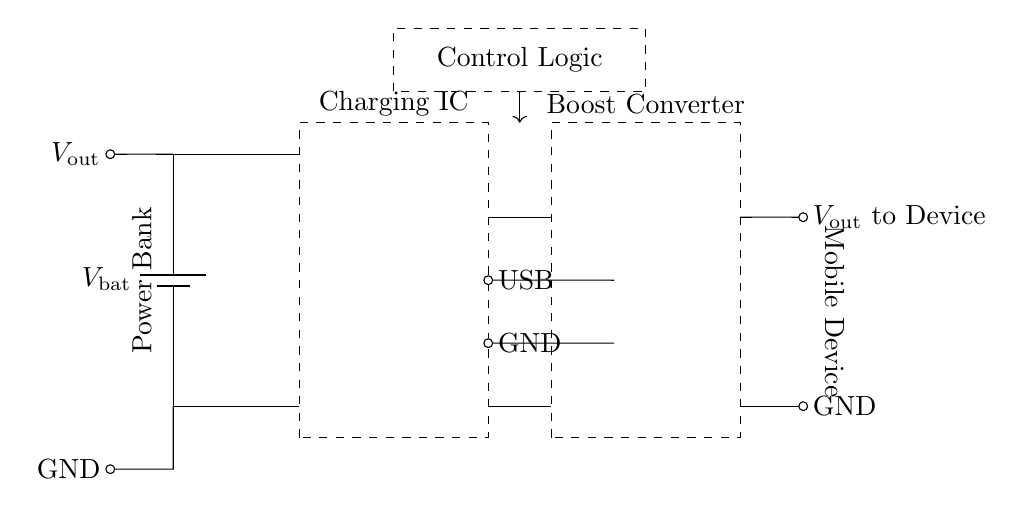What is the function of the boost converter? The boost converter increases the input voltage to a higher output voltage suitable for the mobile device.
Answer: Increase voltage What is the input voltage source for charging? The input for charging is from the USB, which is connected to the charging IC.
Answer: USB What type of component is located in the dashed rectangle on the left? The dashed rectangle contains the charging integrated circuit, which manages the charging process.
Answer: Charging IC What is the output voltage to the mobile device referred to as? The output voltage is labeled as V out, indicating the voltage supplied to the mobile device during operation.
Answer: V out How many main sections are in this power bank circuit? There are four main sections: the power bank, charging IC, boost converter, and control logic, indicating the main functional units in the diagram.
Answer: Four What does the control logic do in this circuit? The control logic regulates the operation of the charging IC and monitors the battery status to ensure safe charging of devices.
Answer: Regulates charging What is the role of the battery in this circuit? The battery supplies the energy needed for the charging process and provides power to the output when the device is connected.
Answer: Power supply 